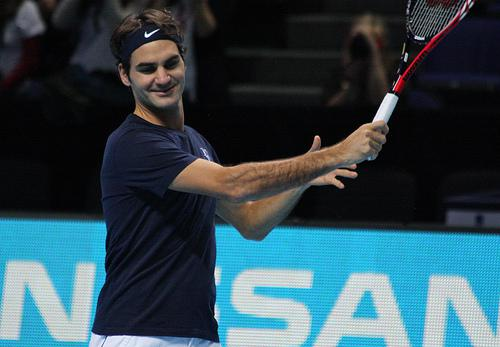Question: what is the man doing?
Choices:
A. Playing tennis.
B. Relaxing.
C. Walking.
D. Surfing.
Answer with the letter. Answer: A Question: how many tennis rackets does the man have?
Choices:
A. Two.
B. Three.
C. One.
D. Four.
Answer with the letter. Answer: C Question: what brand is the headband?
Choices:
A. Nike.
B. Adidas.
C. Reebok.
D. Puma.
Answer with the letter. Answer: A 